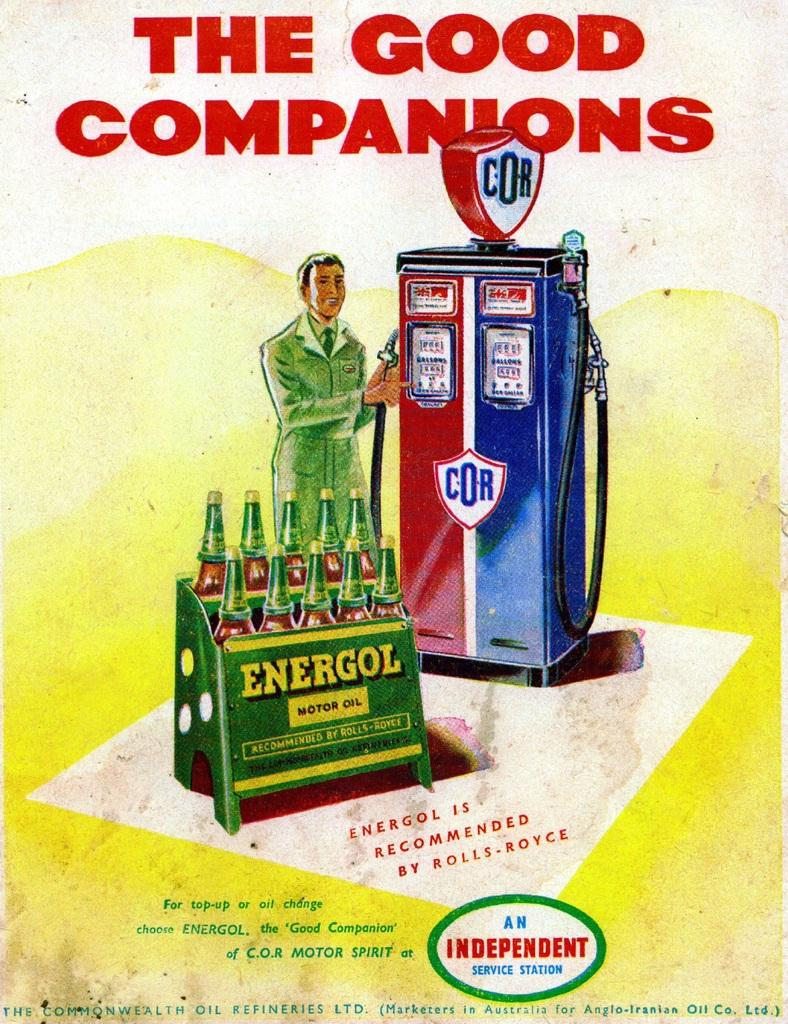<image>
Give a short and clear explanation of the subsequent image. A sign with a man standing next to an old time gas pump and a display of energol motor oil. a sing say an independent service station 